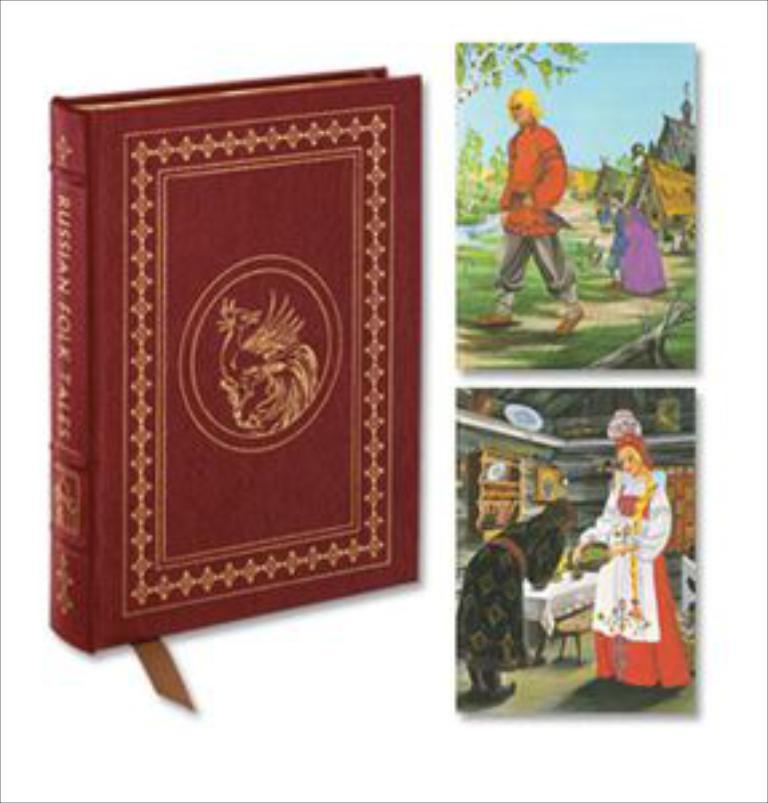What is depicted in the image? There is a picture of a book in the image. Who or what can be seen in the image besides the book? There are people visible in the image. What type of natural environment is present in the image? Grass and trees are visible in the image. What type of man-made structures can be seen in the image? There are buildings in the image. What is visible in the background of the image? The sky is visible in the image. What type of food is being served on the apple in the image? There is no apple or food present in the image. 